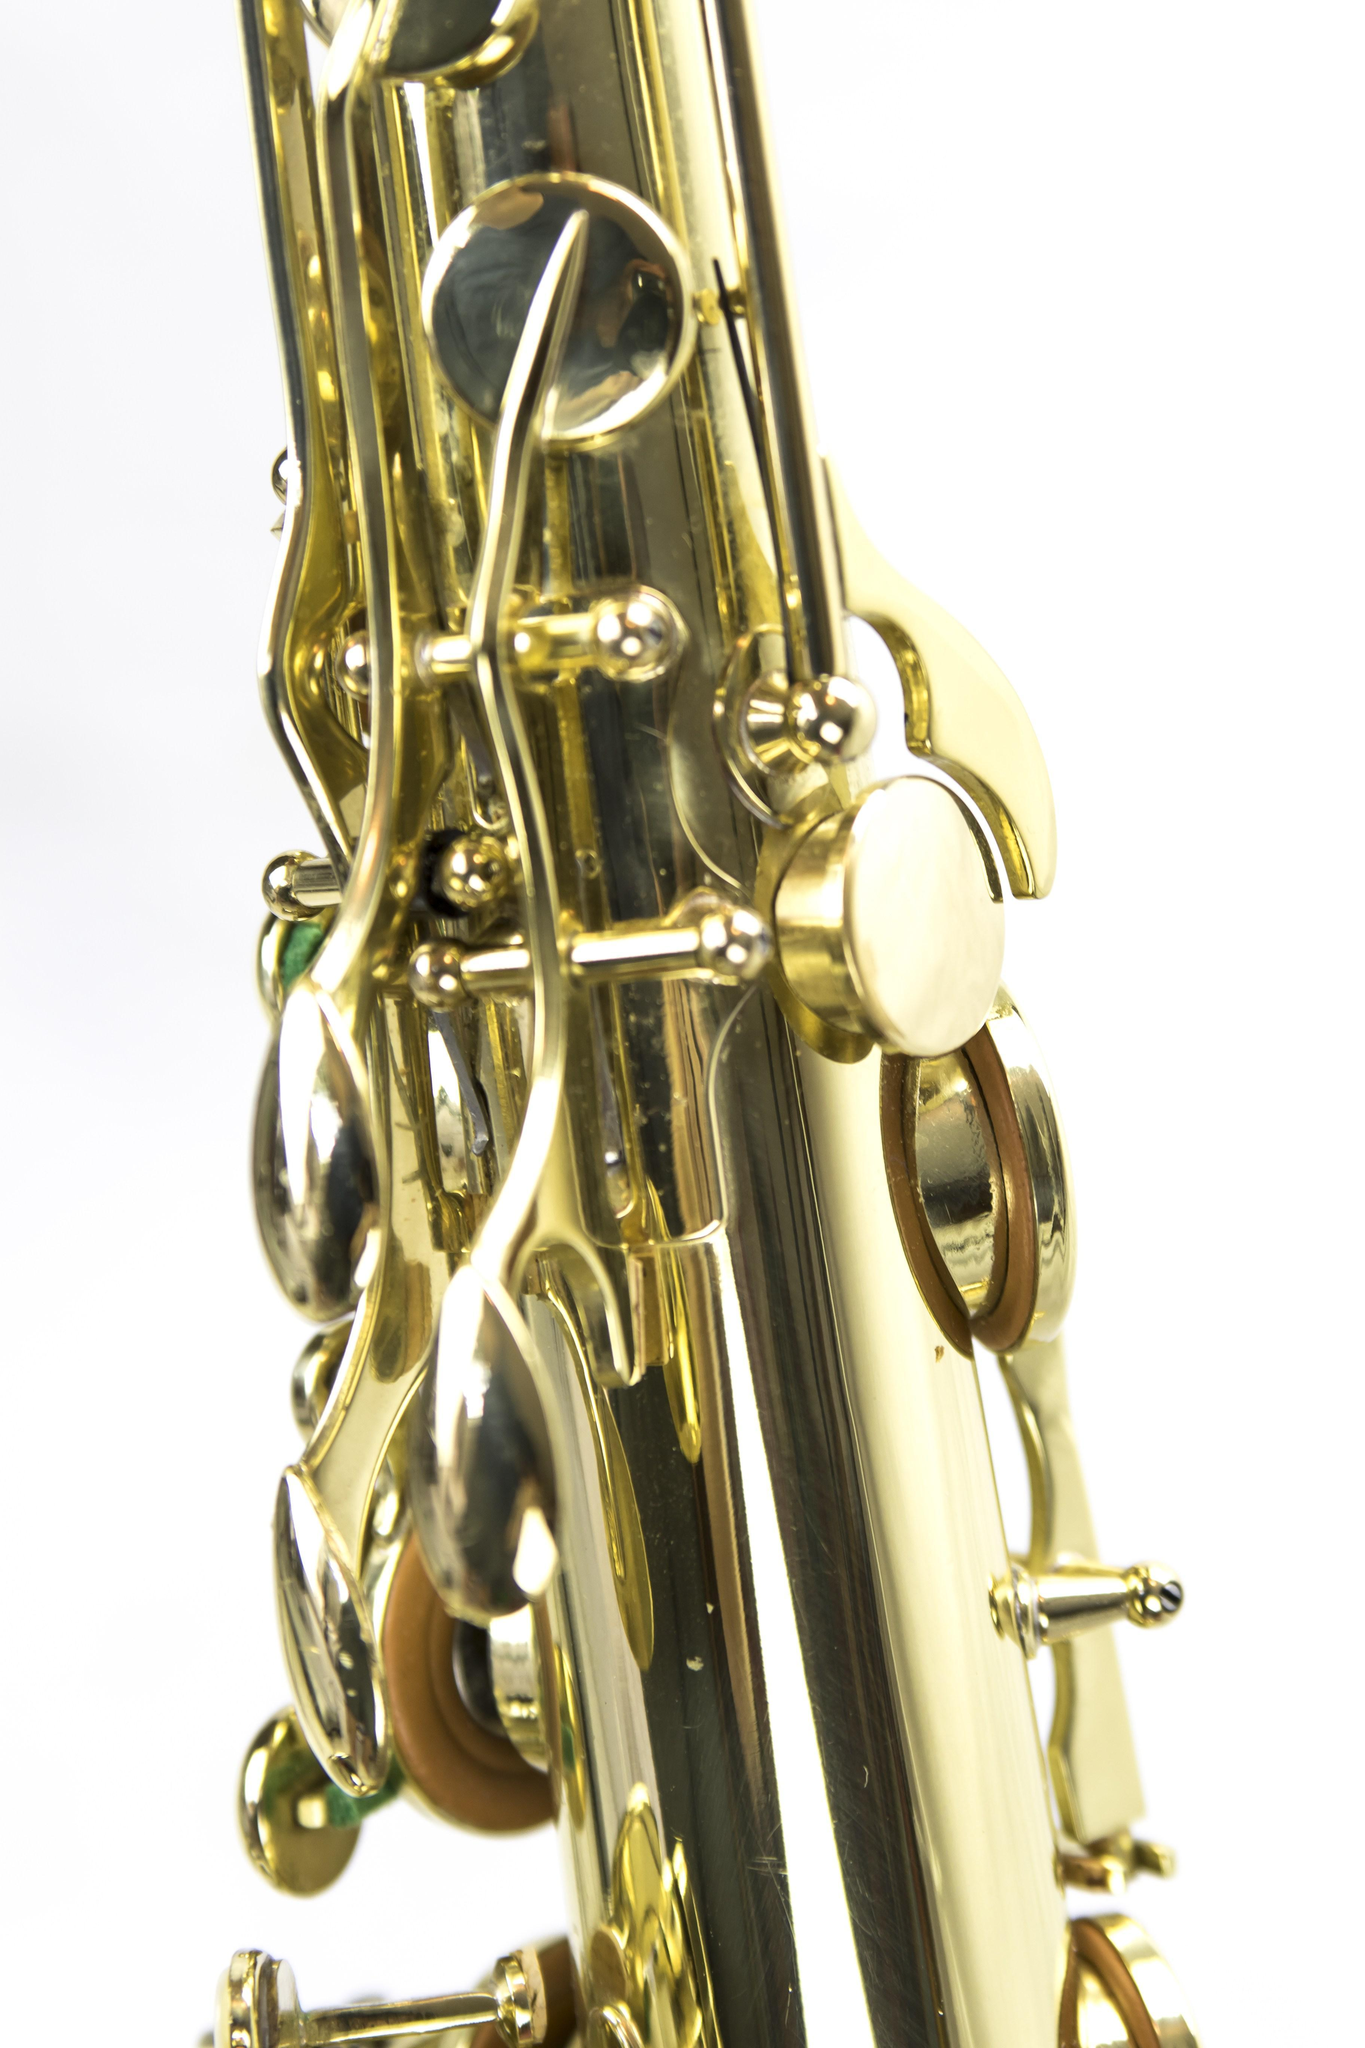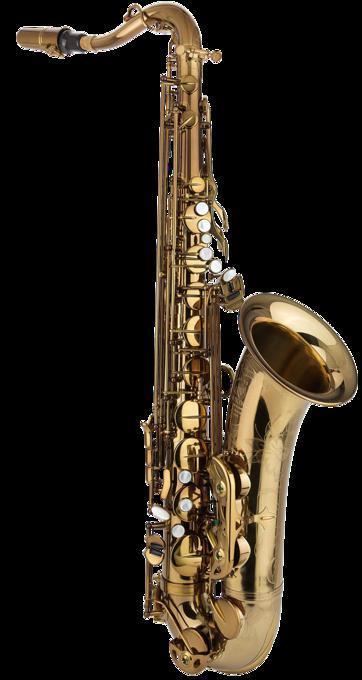The first image is the image on the left, the second image is the image on the right. Considering the images on both sides, is "Each image contains an entire saxophone." valid? Answer yes or no. No. 